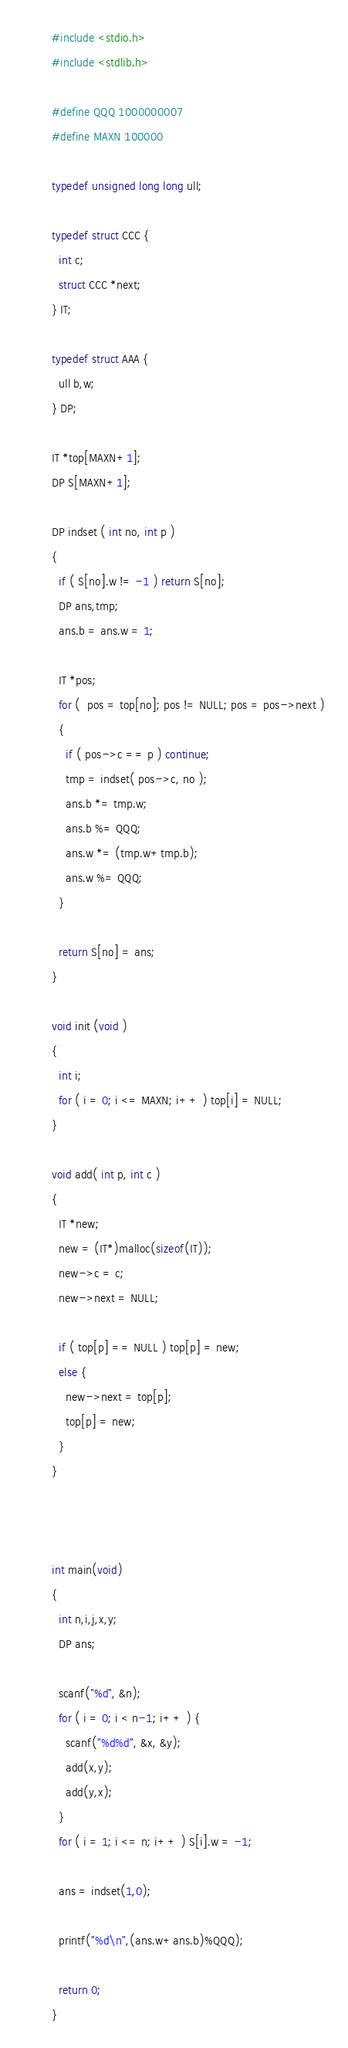<code> <loc_0><loc_0><loc_500><loc_500><_C_>#include <stdio.h>
#include <stdlib.h>

#define QQQ 1000000007
#define MAXN 100000

typedef unsigned long long ull;

typedef struct CCC {
  int c;
  struct CCC *next;
} IT;

typedef struct AAA {
  ull b,w;
} DP;

IT *top[MAXN+1];
DP S[MAXN+1];

DP indset ( int no, int p )
{
  if ( S[no].w != -1 ) return S[no];
  DP ans,tmp;
  ans.b = ans.w = 1;

  IT *pos;
  for (  pos = top[no]; pos != NULL; pos = pos->next )
  {
    if ( pos->c == p ) continue;
    tmp = indset( pos->c, no );
    ans.b *= tmp.w;
    ans.b %= QQQ;
    ans.w *= (tmp.w+tmp.b);
    ans.w %= QQQ;
  }

  return S[no] = ans;
}

void init (void )
{
  int i;
  for ( i = 0; i <= MAXN; i++ ) top[i] = NULL;
}

void add( int p, int c )
{
  IT *new;
  new = (IT*)malloc(sizeof(IT));
  new->c = c;
  new->next = NULL;

  if ( top[p] == NULL ) top[p] = new;
  else {
    new->next = top[p];
    top[p] = new;
  }
}



int main(void)
{
  int n,i,j,x,y;
  DP ans;

  scanf("%d", &n);
  for ( i = 0; i < n-1; i++ ) {
    scanf("%d%d", &x, &y);
    add(x,y);
    add(y,x);
  }
  for ( i = 1; i <= n; i++ ) S[i].w = -1;

  ans = indset(1,0);

  printf("%d\n",(ans.w+ans.b)%QQQ);

  return 0;
}
</code> 